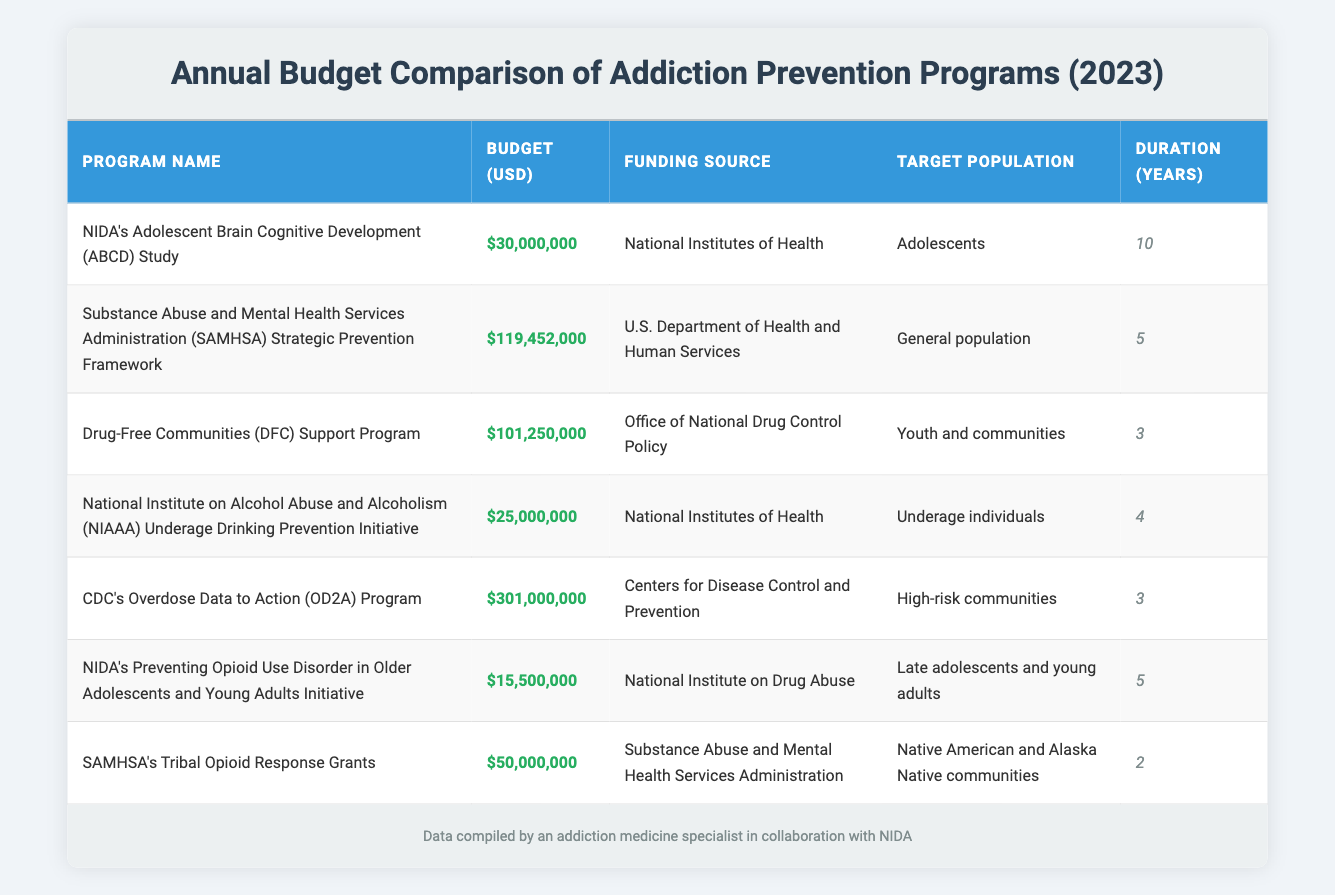What is the total budget allocated for NIDA's Adolescent Brain Cognitive Development Study? The budget allocated for NIDA's Adolescent Brain Cognitive Development Study is listed as $30,000,000 in the table.
Answer: 30000000 Which program has the highest budget? The program with the highest budget is the CDC's Overdose Data to Action Program, with a budget of $301,000,000, as shown in the table.
Answer: CDC's Overdose Data to Action Program How many programs have budgets over $100 million? By examining the budgets in the table, two programs exceed $100 million: the SAMHSA Strategic Prevention Framework and the CDC's Overdose Data to Action Program.
Answer: 2 What is the average budget of the programs listed? To find the average budget, sum the budgets of all programs (30 million + 119.452 million + 101.25 million + 25 million + 301 million + 15.5 million + 50 million) totaling $642.202 million. Dividing this by the 7 programs gives an average of approximately $91.743 million.
Answer: 91743000 Is the Drug-Free Communities Support Program funded by the National Institutes of Health? The Drug-Free Communities Support Program is funded by the Office of National Drug Control Policy according to the table, so the statement is false.
Answer: No What is the combined budget of the NIDA's Preventing Opioid Use Disorder in Older Adolescents and Young Adults Initiative and the NIAAA Underage Drinking Prevention Initiative? The budgets for both initiatives are $15,500,000 and $25,000,000, respectively. Adding these two budgets ($15,500,000 + $25,000,000) results in a combined budget of $40,500,000.
Answer: 40500000 Which target population has the highest budget allocation? The CDC's Overdose Data to Action Program targets high-risk communities and has the highest budget of $301,000,000, indicating that this target population has the highest allocation.
Answer: High-risk communities Is SAMHSA's Tribal Opioid Response Grants program longer than 4 years in duration? The duration of SAMHSA's Tribal Opioid Response Grants program is 2 years, as stated in the table, making the statement false.
Answer: No 